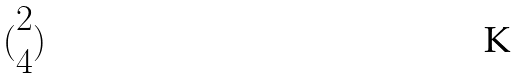<formula> <loc_0><loc_0><loc_500><loc_500>( \begin{matrix} 2 \\ 4 \end{matrix} )</formula> 